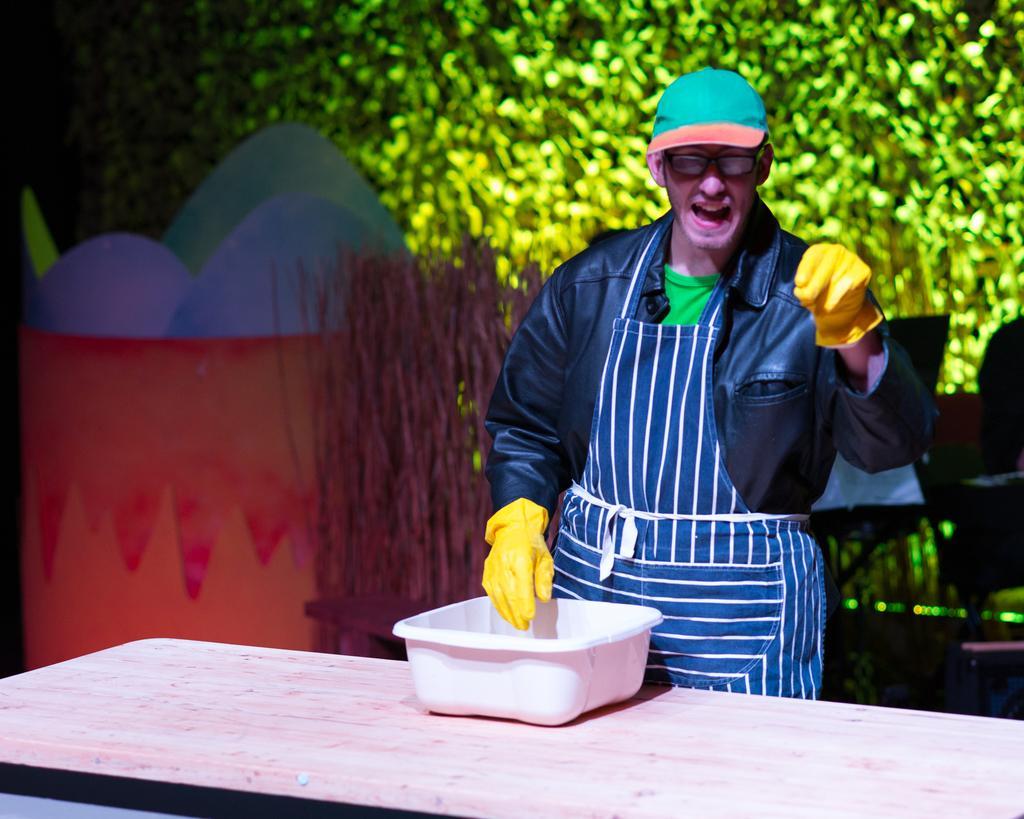In one or two sentences, can you explain what this image depicts? A man is standing at a table with small tub on it. 